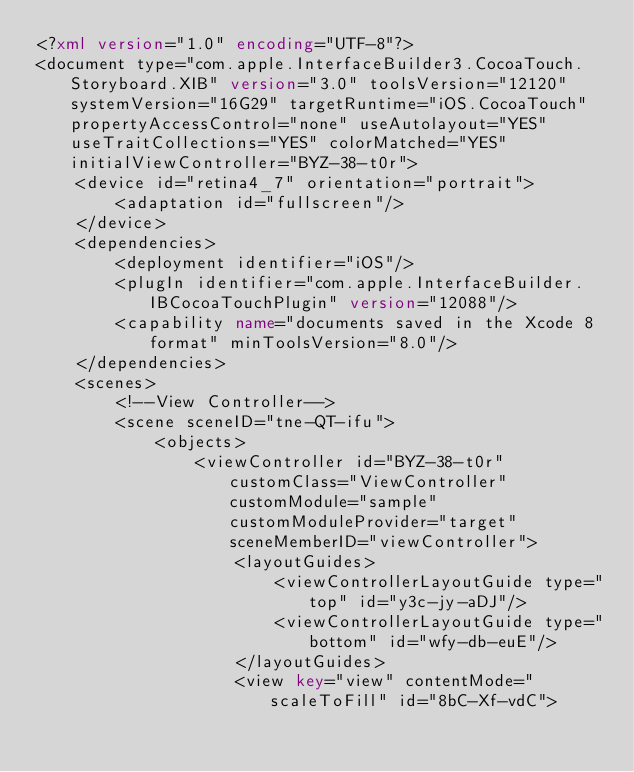<code> <loc_0><loc_0><loc_500><loc_500><_XML_><?xml version="1.0" encoding="UTF-8"?>
<document type="com.apple.InterfaceBuilder3.CocoaTouch.Storyboard.XIB" version="3.0" toolsVersion="12120" systemVersion="16G29" targetRuntime="iOS.CocoaTouch" propertyAccessControl="none" useAutolayout="YES" useTraitCollections="YES" colorMatched="YES" initialViewController="BYZ-38-t0r">
    <device id="retina4_7" orientation="portrait">
        <adaptation id="fullscreen"/>
    </device>
    <dependencies>
        <deployment identifier="iOS"/>
        <plugIn identifier="com.apple.InterfaceBuilder.IBCocoaTouchPlugin" version="12088"/>
        <capability name="documents saved in the Xcode 8 format" minToolsVersion="8.0"/>
    </dependencies>
    <scenes>
        <!--View Controller-->
        <scene sceneID="tne-QT-ifu">
            <objects>
                <viewController id="BYZ-38-t0r" customClass="ViewController" customModule="sample" customModuleProvider="target" sceneMemberID="viewController">
                    <layoutGuides>
                        <viewControllerLayoutGuide type="top" id="y3c-jy-aDJ"/>
                        <viewControllerLayoutGuide type="bottom" id="wfy-db-euE"/>
                    </layoutGuides>
                    <view key="view" contentMode="scaleToFill" id="8bC-Xf-vdC"></code> 